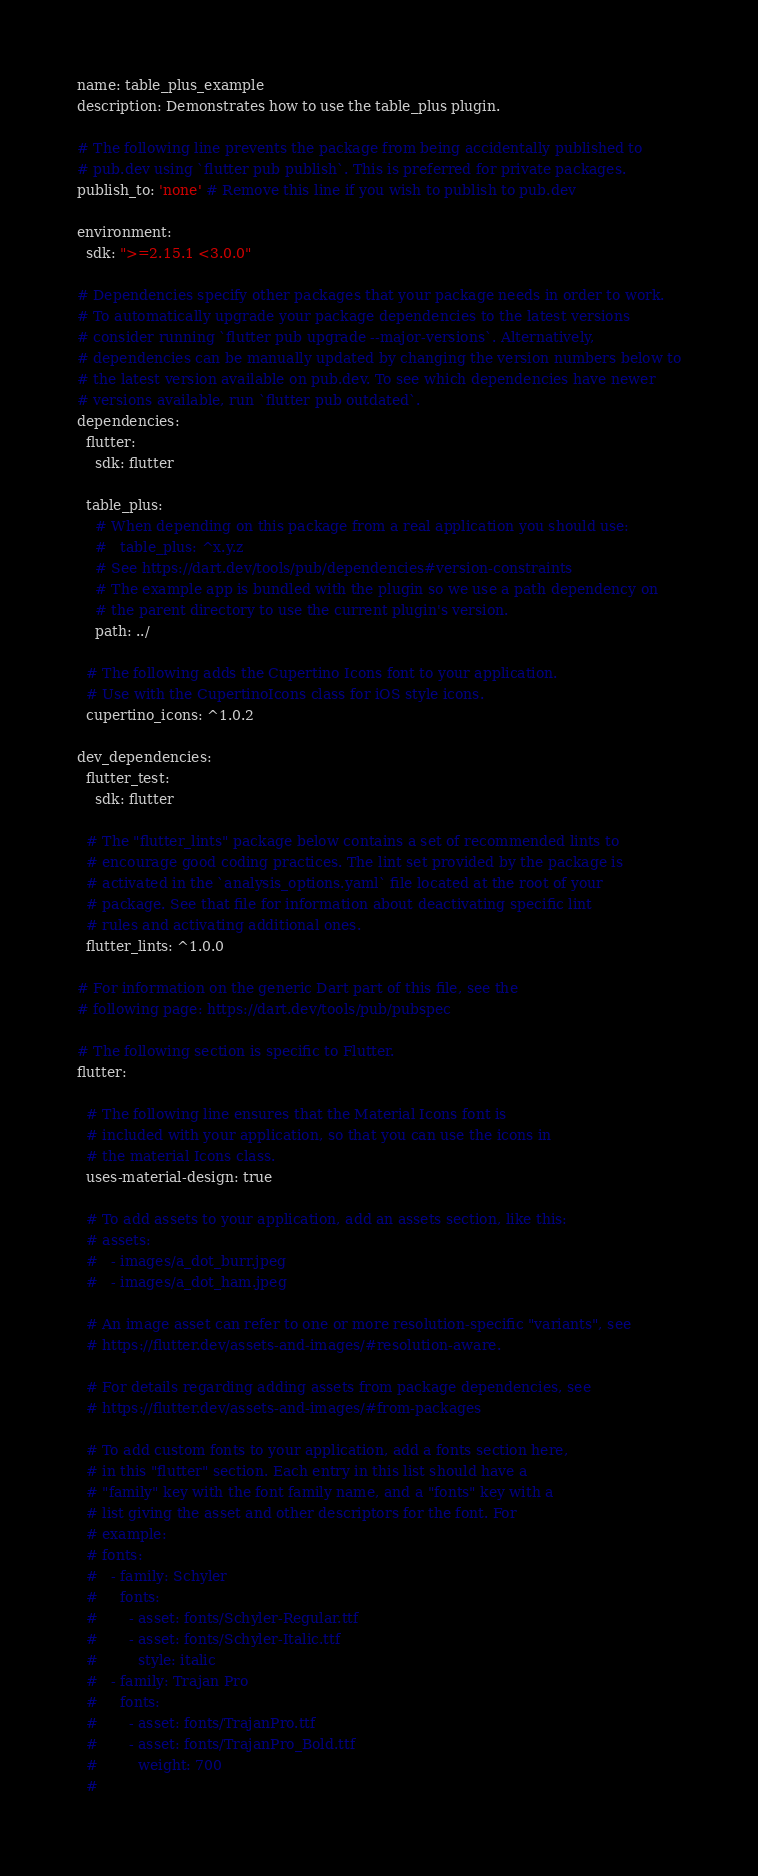Convert code to text. <code><loc_0><loc_0><loc_500><loc_500><_YAML_>name: table_plus_example
description: Demonstrates how to use the table_plus plugin.

# The following line prevents the package from being accidentally published to
# pub.dev using `flutter pub publish`. This is preferred for private packages.
publish_to: 'none' # Remove this line if you wish to publish to pub.dev

environment:
  sdk: ">=2.15.1 <3.0.0"

# Dependencies specify other packages that your package needs in order to work.
# To automatically upgrade your package dependencies to the latest versions
# consider running `flutter pub upgrade --major-versions`. Alternatively,
# dependencies can be manually updated by changing the version numbers below to
# the latest version available on pub.dev. To see which dependencies have newer
# versions available, run `flutter pub outdated`.
dependencies:
  flutter:
    sdk: flutter

  table_plus:
    # When depending on this package from a real application you should use:
    #   table_plus: ^x.y.z
    # See https://dart.dev/tools/pub/dependencies#version-constraints
    # The example app is bundled with the plugin so we use a path dependency on
    # the parent directory to use the current plugin's version.
    path: ../

  # The following adds the Cupertino Icons font to your application.
  # Use with the CupertinoIcons class for iOS style icons.
  cupertino_icons: ^1.0.2

dev_dependencies:
  flutter_test:
    sdk: flutter

  # The "flutter_lints" package below contains a set of recommended lints to
  # encourage good coding practices. The lint set provided by the package is
  # activated in the `analysis_options.yaml` file located at the root of your
  # package. See that file for information about deactivating specific lint
  # rules and activating additional ones.
  flutter_lints: ^1.0.0

# For information on the generic Dart part of this file, see the
# following page: https://dart.dev/tools/pub/pubspec

# The following section is specific to Flutter.
flutter:

  # The following line ensures that the Material Icons font is
  # included with your application, so that you can use the icons in
  # the material Icons class.
  uses-material-design: true

  # To add assets to your application, add an assets section, like this:
  # assets:
  #   - images/a_dot_burr.jpeg
  #   - images/a_dot_ham.jpeg

  # An image asset can refer to one or more resolution-specific "variants", see
  # https://flutter.dev/assets-and-images/#resolution-aware.

  # For details regarding adding assets from package dependencies, see
  # https://flutter.dev/assets-and-images/#from-packages

  # To add custom fonts to your application, add a fonts section here,
  # in this "flutter" section. Each entry in this list should have a
  # "family" key with the font family name, and a "fonts" key with a
  # list giving the asset and other descriptors for the font. For
  # example:
  # fonts:
  #   - family: Schyler
  #     fonts:
  #       - asset: fonts/Schyler-Regular.ttf
  #       - asset: fonts/Schyler-Italic.ttf
  #         style: italic
  #   - family: Trajan Pro
  #     fonts:
  #       - asset: fonts/TrajanPro.ttf
  #       - asset: fonts/TrajanPro_Bold.ttf
  #         weight: 700
  #</code> 